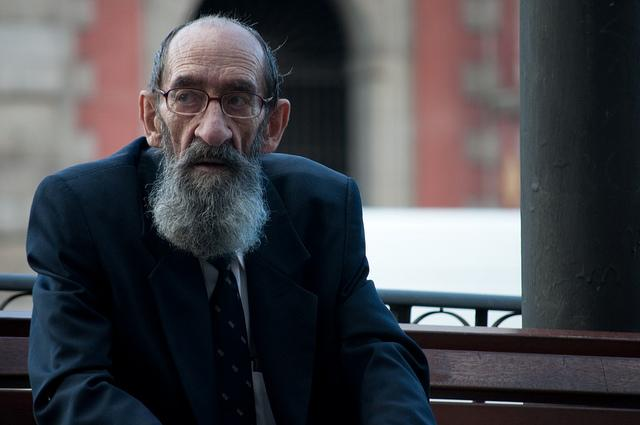What color is the jacket blazer worn by the man with the beard?

Choices:
A) white
B) yellow
C) red
D) blue blue 